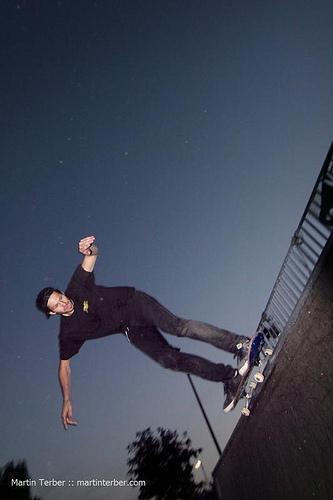How many wheels are on this skateboard?
Give a very brief answer. 4. How many people are in the picture?
Give a very brief answer. 1. 